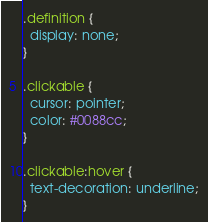<code> <loc_0><loc_0><loc_500><loc_500><_CSS_>.definition {
  display: none;
}

.clickable {
  cursor: pointer;
  color: #0088cc;
}

.clickable:hover {
  text-decoration: underline;
}</code> 